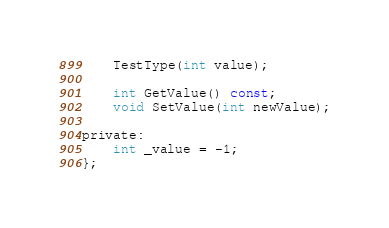<code> <loc_0><loc_0><loc_500><loc_500><_C_>    TestType(int value);

    int GetValue() const;
    void SetValue(int newValue);

private:
    int _value = -1;
};
</code> 